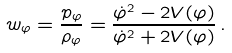Convert formula to latex. <formula><loc_0><loc_0><loc_500><loc_500>w _ { \varphi } = \frac { p _ { \varphi } } { { \rho } _ { \varphi } } = \frac { { \dot { \varphi } } ^ { 2 } - 2 V ( \varphi ) } { { \dot { \varphi } } ^ { 2 } + 2 V ( \varphi ) } \, .</formula> 